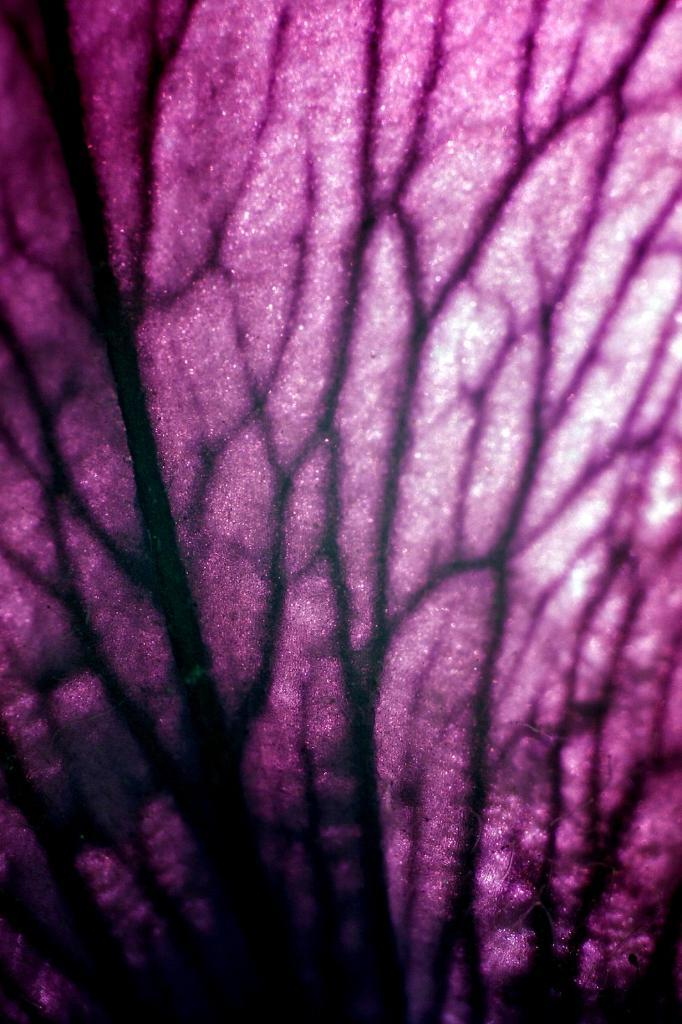What type of natural elements can be seen in the image? There are tree branches in the image. What colors are present in the background of the image? The background of the image includes pink and black colors. What type of horn is visible on the tree branches in the image? There is no horn present on the tree branches in the image. What invention is being demonstrated in the image? There is no invention being demonstrated in the image; it simply features tree branches and background colors. 